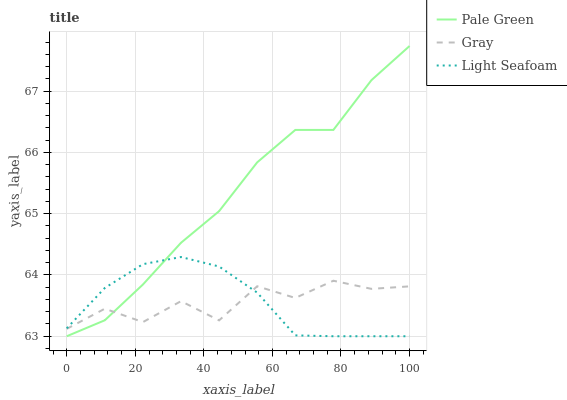Does Gray have the minimum area under the curve?
Answer yes or no. Yes. Does Pale Green have the maximum area under the curve?
Answer yes or no. Yes. Does Light Seafoam have the minimum area under the curve?
Answer yes or no. No. Does Light Seafoam have the maximum area under the curve?
Answer yes or no. No. Is Light Seafoam the smoothest?
Answer yes or no. Yes. Is Gray the roughest?
Answer yes or no. Yes. Is Pale Green the smoothest?
Answer yes or no. No. Is Pale Green the roughest?
Answer yes or no. No. Does Pale Green have the lowest value?
Answer yes or no. Yes. Does Pale Green have the highest value?
Answer yes or no. Yes. Does Light Seafoam have the highest value?
Answer yes or no. No. Does Light Seafoam intersect Pale Green?
Answer yes or no. Yes. Is Light Seafoam less than Pale Green?
Answer yes or no. No. Is Light Seafoam greater than Pale Green?
Answer yes or no. No. 